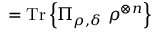<formula> <loc_0><loc_0><loc_500><loc_500>= { T r } \left \{ \Pi _ { \rho , \delta } \ \rho ^ { \otimes n } \right \}</formula> 